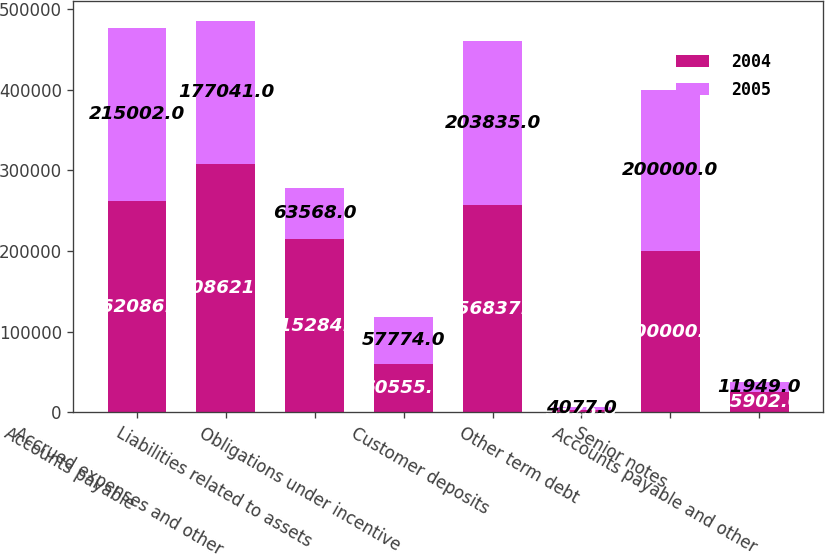<chart> <loc_0><loc_0><loc_500><loc_500><stacked_bar_chart><ecel><fcel>Accounts payable<fcel>Accrued expenses and other<fcel>Liabilities related to assets<fcel>Obligations under incentive<fcel>Customer deposits<fcel>Other term debt<fcel>Senior notes<fcel>Accounts payable and other<nl><fcel>2004<fcel>262086<fcel>308621<fcel>215284<fcel>60555<fcel>256837<fcel>3325<fcel>200000<fcel>25902<nl><fcel>2005<fcel>215002<fcel>177041<fcel>63568<fcel>57774<fcel>203835<fcel>4077<fcel>200000<fcel>11949<nl></chart> 